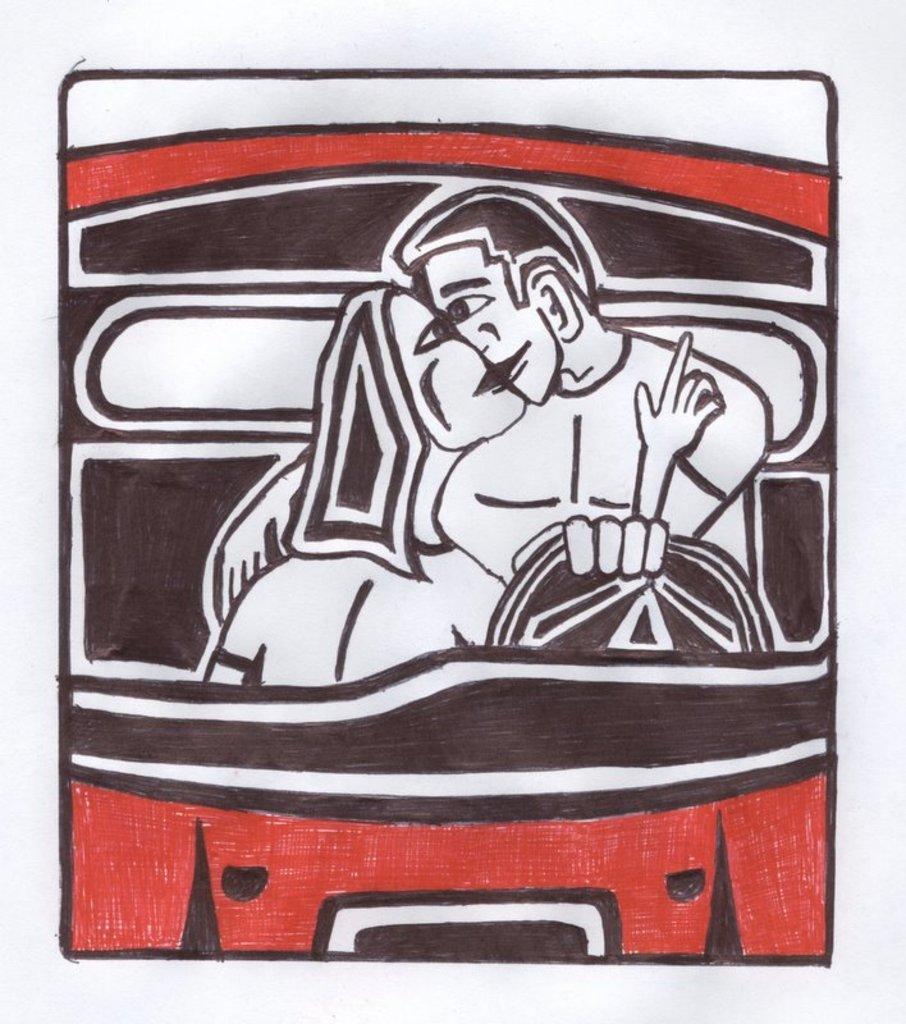Please provide a concise description of this image. There is a poster having animated image which is having two persons sitting on the seats of a vehicle. 